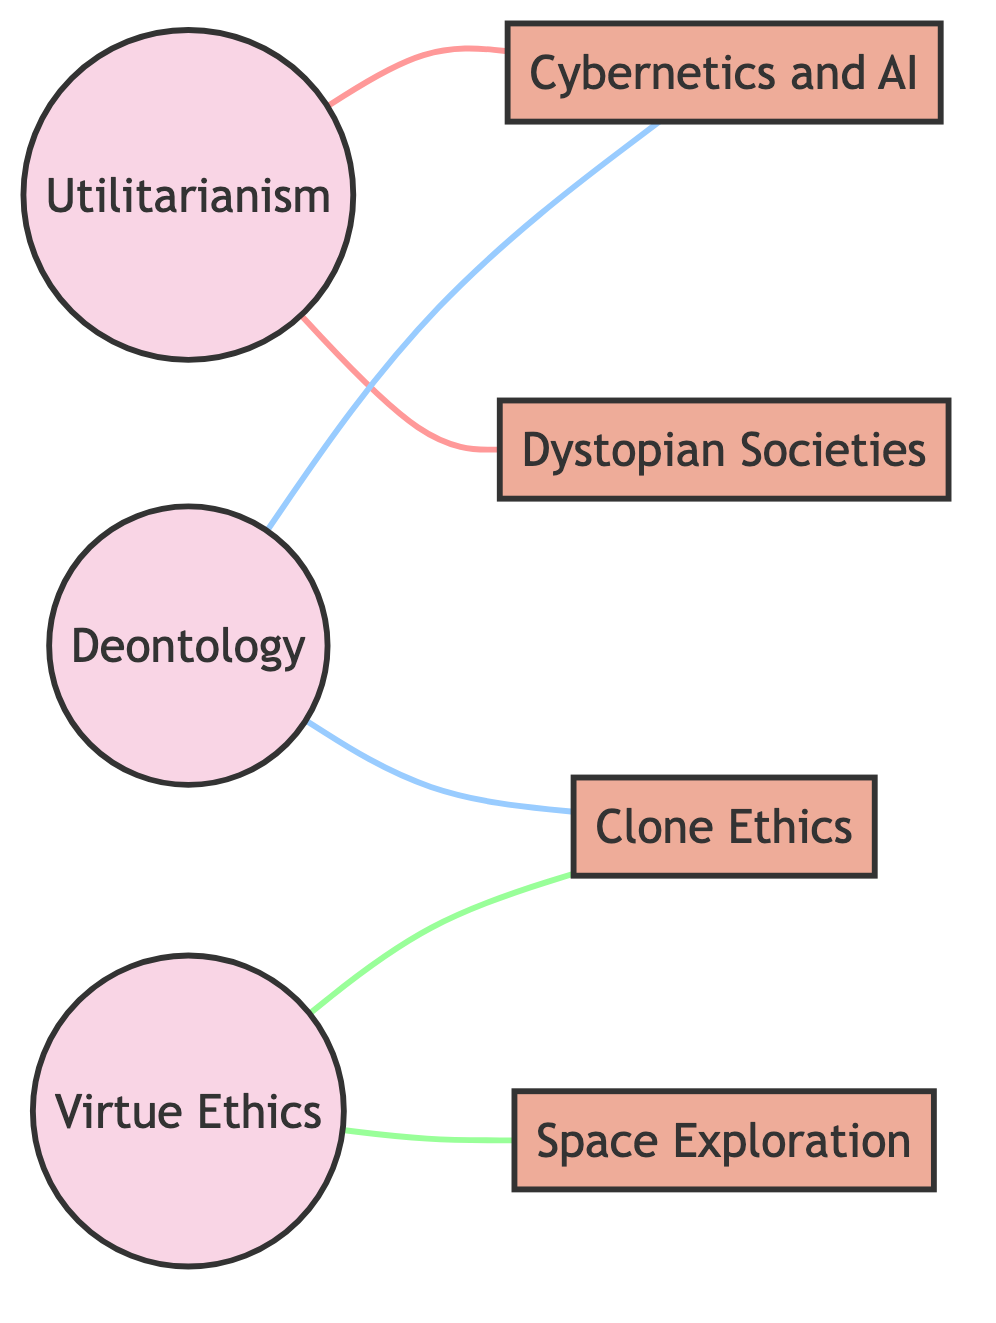What ethical theory emphasizes duties and rules? The node labeled "Deontology" directly identifies itself as an ethical theory emphasizing duties and rules.
Answer: Deontology What is the thematic element depicted alongside "Clone Ethics"? The diagram shows a direct connection between "Clone Ethics" and "Deontology," indicating a thematic element that considers identity and rights based on established rules.
Answer: Deontology How many nodes are there in the diagram? Counting all the unique nodes listed (Utilitarianism, Deontology, Virtue Ethics, Cybernetics and AI, Dystopian Societies, Clone Ethics, Space Exploration) gives a total of 7.
Answer: 7 Which ethical theory is connected to "Cybernetics and AI" by a reasoning relationship? "Utilitarianism" connects to "Cybernetics and AI" based on the principle of AI decision-making aimed at maximizing utility, showing an ethical reasoning link.
Answer: Utilitarianism What specific connection exists between "Virtue Ethics" and "Space Exploration"? The label on the edge indicates that "Virtue Ethics" is linked to "Space Exploration" by character-driven decisions in space colonization, reflecting ethical considerations.
Answer: Character-driven decisions in space colonization How many edges connect "Deontology" to other concepts? Analyzing the edges from "Deontology," there are exactly two edges leading to "Cybernetics and AI" and "Clone Ethics." Thus, it connects to two different concepts.
Answer: 2 Which theory is associated with the concept of creating sentient beings? The node "Cybernetics and AI" relates to ethical implications around creating sentient beings, indicating this specific theory association.
Answer: Cybernetics and AI Out of the ethical theories, which one aligns with maximizing overall happiness? The connection to "Utilitarianism" underscores that it is the ethical theory positing that actions should aim to maximize overall happiness or utility.
Answer: Utilitarianism What ethical theory entails the ethical treatment of clones? "Virtue Ethics" is tied to "Clone Ethics" in the sense of ethical treatment being considered based on virtues, thereby reflecting this ethical theory.
Answer: Virtue Ethics 